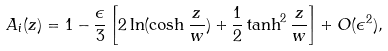Convert formula to latex. <formula><loc_0><loc_0><loc_500><loc_500>A _ { i } ( z ) = 1 - \frac { \epsilon } { 3 } \left [ 2 \ln ( \cosh \frac { z } { w } ) + \frac { 1 } { 2 } \tanh ^ { 2 } \frac { z } { w } \right ] + O ( \epsilon ^ { 2 } ) ,</formula> 